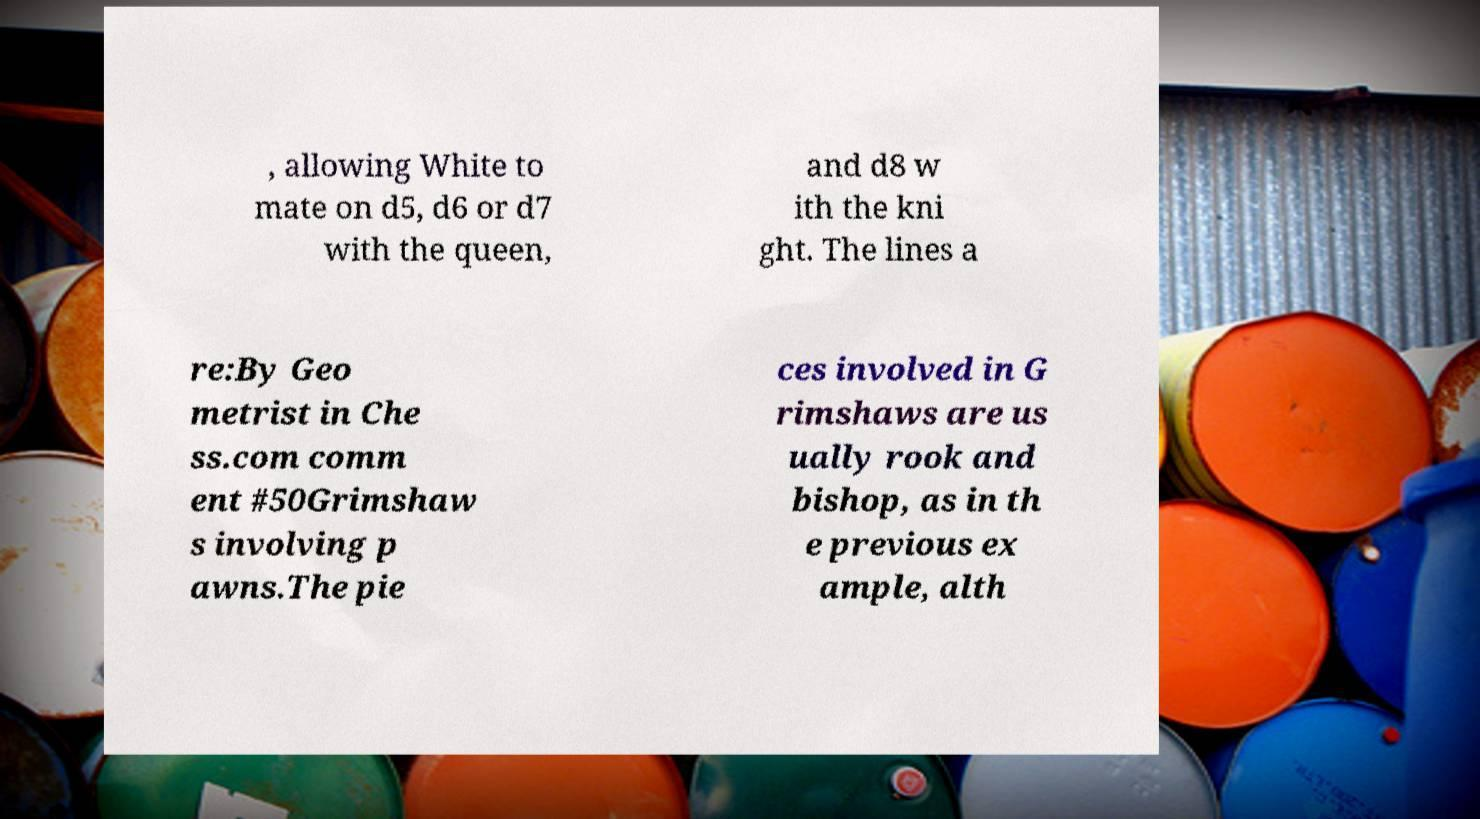What messages or text are displayed in this image? I need them in a readable, typed format. , allowing White to mate on d5, d6 or d7 with the queen, and d8 w ith the kni ght. The lines a re:By Geo metrist in Che ss.com comm ent #50Grimshaw s involving p awns.The pie ces involved in G rimshaws are us ually rook and bishop, as in th e previous ex ample, alth 